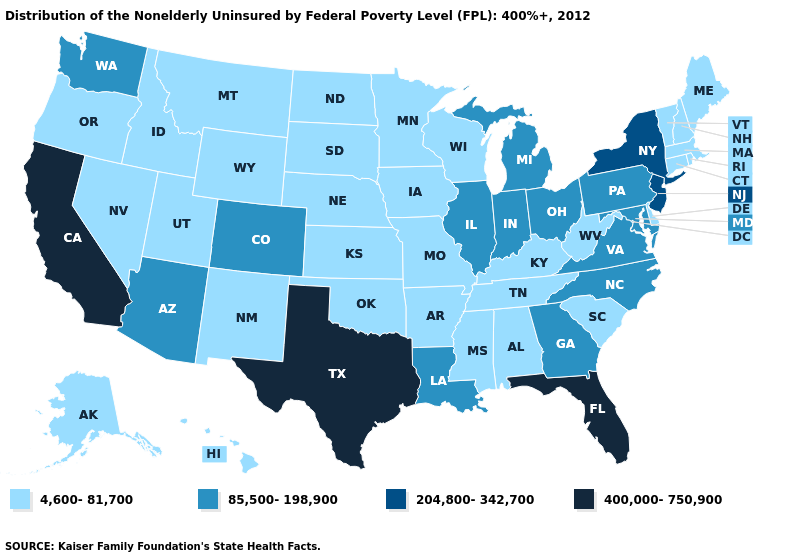What is the value of Louisiana?
Answer briefly. 85,500-198,900. How many symbols are there in the legend?
Be succinct. 4. What is the lowest value in the MidWest?
Answer briefly. 4,600-81,700. Name the states that have a value in the range 4,600-81,700?
Write a very short answer. Alabama, Alaska, Arkansas, Connecticut, Delaware, Hawaii, Idaho, Iowa, Kansas, Kentucky, Maine, Massachusetts, Minnesota, Mississippi, Missouri, Montana, Nebraska, Nevada, New Hampshire, New Mexico, North Dakota, Oklahoma, Oregon, Rhode Island, South Carolina, South Dakota, Tennessee, Utah, Vermont, West Virginia, Wisconsin, Wyoming. What is the value of Alabama?
Give a very brief answer. 4,600-81,700. What is the value of Illinois?
Give a very brief answer. 85,500-198,900. Does California have the highest value in the West?
Give a very brief answer. Yes. Name the states that have a value in the range 400,000-750,900?
Quick response, please. California, Florida, Texas. Among the states that border Delaware , does New Jersey have the highest value?
Concise answer only. Yes. What is the highest value in the MidWest ?
Give a very brief answer. 85,500-198,900. What is the highest value in states that border Louisiana?
Write a very short answer. 400,000-750,900. How many symbols are there in the legend?
Concise answer only. 4. What is the value of Connecticut?
Write a very short answer. 4,600-81,700. Name the states that have a value in the range 400,000-750,900?
Short answer required. California, Florida, Texas. Name the states that have a value in the range 400,000-750,900?
Be succinct. California, Florida, Texas. 